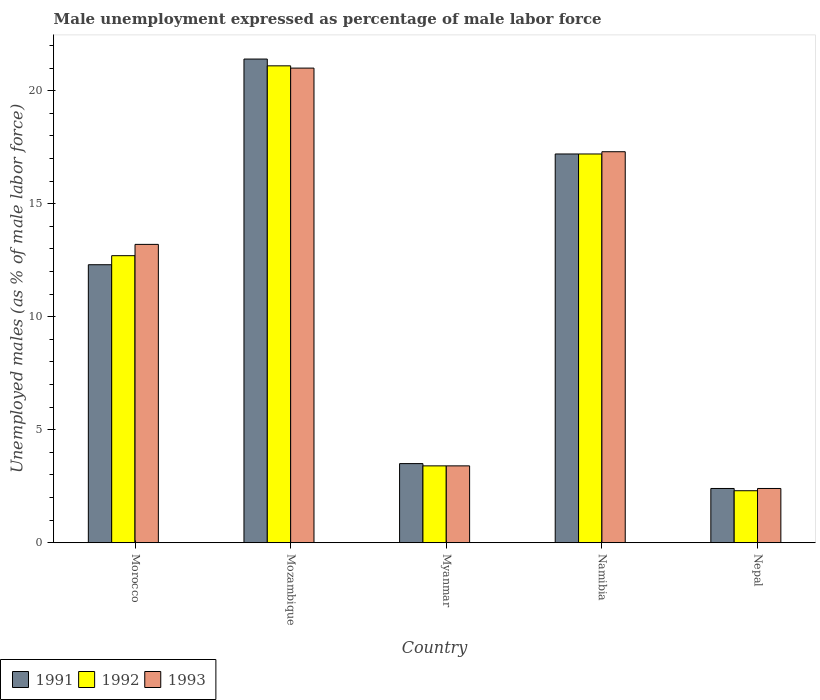How many bars are there on the 2nd tick from the left?
Keep it short and to the point. 3. What is the label of the 1st group of bars from the left?
Your response must be concise. Morocco. What is the unemployment in males in in 1992 in Myanmar?
Provide a short and direct response. 3.4. Across all countries, what is the maximum unemployment in males in in 1992?
Your answer should be compact. 21.1. Across all countries, what is the minimum unemployment in males in in 1993?
Offer a very short reply. 2.4. In which country was the unemployment in males in in 1993 maximum?
Provide a succinct answer. Mozambique. In which country was the unemployment in males in in 1992 minimum?
Your response must be concise. Nepal. What is the total unemployment in males in in 1993 in the graph?
Provide a succinct answer. 57.3. What is the difference between the unemployment in males in in 1993 in Mozambique and that in Namibia?
Your answer should be compact. 3.7. What is the difference between the unemployment in males in in 1993 in Mozambique and the unemployment in males in in 1991 in Morocco?
Provide a short and direct response. 8.7. What is the average unemployment in males in in 1992 per country?
Offer a very short reply. 11.34. What is the difference between the unemployment in males in of/in 1992 and unemployment in males in of/in 1991 in Morocco?
Your answer should be very brief. 0.4. What is the ratio of the unemployment in males in in 1992 in Mozambique to that in Nepal?
Provide a short and direct response. 9.17. Is the difference between the unemployment in males in in 1992 in Myanmar and Namibia greater than the difference between the unemployment in males in in 1991 in Myanmar and Namibia?
Give a very brief answer. No. What is the difference between the highest and the second highest unemployment in males in in 1991?
Give a very brief answer. 4.9. What is the difference between the highest and the lowest unemployment in males in in 1991?
Provide a short and direct response. 19. In how many countries, is the unemployment in males in in 1991 greater than the average unemployment in males in in 1991 taken over all countries?
Ensure brevity in your answer.  3. Is the sum of the unemployment in males in in 1991 in Mozambique and Nepal greater than the maximum unemployment in males in in 1993 across all countries?
Offer a terse response. Yes. What does the 3rd bar from the right in Nepal represents?
Provide a succinct answer. 1991. Is it the case that in every country, the sum of the unemployment in males in in 1993 and unemployment in males in in 1991 is greater than the unemployment in males in in 1992?
Ensure brevity in your answer.  Yes. How many bars are there?
Offer a very short reply. 15. Are all the bars in the graph horizontal?
Give a very brief answer. No. How many countries are there in the graph?
Provide a short and direct response. 5. Are the values on the major ticks of Y-axis written in scientific E-notation?
Provide a short and direct response. No. Does the graph contain grids?
Your response must be concise. No. Where does the legend appear in the graph?
Your answer should be very brief. Bottom left. How are the legend labels stacked?
Offer a terse response. Horizontal. What is the title of the graph?
Your answer should be very brief. Male unemployment expressed as percentage of male labor force. Does "2014" appear as one of the legend labels in the graph?
Give a very brief answer. No. What is the label or title of the Y-axis?
Your answer should be compact. Unemployed males (as % of male labor force). What is the Unemployed males (as % of male labor force) in 1991 in Morocco?
Provide a short and direct response. 12.3. What is the Unemployed males (as % of male labor force) of 1992 in Morocco?
Keep it short and to the point. 12.7. What is the Unemployed males (as % of male labor force) of 1993 in Morocco?
Make the answer very short. 13.2. What is the Unemployed males (as % of male labor force) of 1991 in Mozambique?
Provide a succinct answer. 21.4. What is the Unemployed males (as % of male labor force) in 1992 in Mozambique?
Your answer should be compact. 21.1. What is the Unemployed males (as % of male labor force) of 1992 in Myanmar?
Your response must be concise. 3.4. What is the Unemployed males (as % of male labor force) in 1993 in Myanmar?
Provide a succinct answer. 3.4. What is the Unemployed males (as % of male labor force) in 1991 in Namibia?
Your answer should be compact. 17.2. What is the Unemployed males (as % of male labor force) in 1992 in Namibia?
Your response must be concise. 17.2. What is the Unemployed males (as % of male labor force) of 1993 in Namibia?
Make the answer very short. 17.3. What is the Unemployed males (as % of male labor force) in 1991 in Nepal?
Give a very brief answer. 2.4. What is the Unemployed males (as % of male labor force) of 1992 in Nepal?
Provide a short and direct response. 2.3. What is the Unemployed males (as % of male labor force) in 1993 in Nepal?
Offer a terse response. 2.4. Across all countries, what is the maximum Unemployed males (as % of male labor force) of 1991?
Provide a succinct answer. 21.4. Across all countries, what is the maximum Unemployed males (as % of male labor force) of 1992?
Your answer should be very brief. 21.1. Across all countries, what is the minimum Unemployed males (as % of male labor force) of 1991?
Provide a short and direct response. 2.4. Across all countries, what is the minimum Unemployed males (as % of male labor force) of 1992?
Keep it short and to the point. 2.3. Across all countries, what is the minimum Unemployed males (as % of male labor force) in 1993?
Offer a very short reply. 2.4. What is the total Unemployed males (as % of male labor force) in 1991 in the graph?
Your answer should be very brief. 56.8. What is the total Unemployed males (as % of male labor force) in 1992 in the graph?
Keep it short and to the point. 56.7. What is the total Unemployed males (as % of male labor force) in 1993 in the graph?
Your answer should be very brief. 57.3. What is the difference between the Unemployed males (as % of male labor force) in 1992 in Morocco and that in Mozambique?
Your response must be concise. -8.4. What is the difference between the Unemployed males (as % of male labor force) of 1991 in Morocco and that in Myanmar?
Make the answer very short. 8.8. What is the difference between the Unemployed males (as % of male labor force) in 1993 in Morocco and that in Myanmar?
Keep it short and to the point. 9.8. What is the difference between the Unemployed males (as % of male labor force) in 1992 in Morocco and that in Nepal?
Give a very brief answer. 10.4. What is the difference between the Unemployed males (as % of male labor force) of 1992 in Mozambique and that in Myanmar?
Keep it short and to the point. 17.7. What is the difference between the Unemployed males (as % of male labor force) of 1991 in Mozambique and that in Nepal?
Provide a short and direct response. 19. What is the difference between the Unemployed males (as % of male labor force) of 1993 in Mozambique and that in Nepal?
Ensure brevity in your answer.  18.6. What is the difference between the Unemployed males (as % of male labor force) in 1991 in Myanmar and that in Namibia?
Give a very brief answer. -13.7. What is the difference between the Unemployed males (as % of male labor force) of 1993 in Myanmar and that in Namibia?
Make the answer very short. -13.9. What is the difference between the Unemployed males (as % of male labor force) in 1991 in Myanmar and that in Nepal?
Ensure brevity in your answer.  1.1. What is the difference between the Unemployed males (as % of male labor force) of 1992 in Myanmar and that in Nepal?
Keep it short and to the point. 1.1. What is the difference between the Unemployed males (as % of male labor force) of 1993 in Myanmar and that in Nepal?
Provide a succinct answer. 1. What is the difference between the Unemployed males (as % of male labor force) in 1991 in Namibia and that in Nepal?
Keep it short and to the point. 14.8. What is the difference between the Unemployed males (as % of male labor force) in 1991 in Morocco and the Unemployed males (as % of male labor force) in 1992 in Mozambique?
Your answer should be compact. -8.8. What is the difference between the Unemployed males (as % of male labor force) of 1991 in Morocco and the Unemployed males (as % of male labor force) of 1993 in Mozambique?
Provide a succinct answer. -8.7. What is the difference between the Unemployed males (as % of male labor force) of 1992 in Morocco and the Unemployed males (as % of male labor force) of 1993 in Mozambique?
Provide a short and direct response. -8.3. What is the difference between the Unemployed males (as % of male labor force) of 1991 in Morocco and the Unemployed males (as % of male labor force) of 1993 in Myanmar?
Make the answer very short. 8.9. What is the difference between the Unemployed males (as % of male labor force) of 1991 in Morocco and the Unemployed males (as % of male labor force) of 1993 in Namibia?
Provide a short and direct response. -5. What is the difference between the Unemployed males (as % of male labor force) in 1992 in Morocco and the Unemployed males (as % of male labor force) in 1993 in Namibia?
Your answer should be very brief. -4.6. What is the difference between the Unemployed males (as % of male labor force) in 1991 in Morocco and the Unemployed males (as % of male labor force) in 1992 in Nepal?
Ensure brevity in your answer.  10. What is the difference between the Unemployed males (as % of male labor force) of 1991 in Morocco and the Unemployed males (as % of male labor force) of 1993 in Nepal?
Give a very brief answer. 9.9. What is the difference between the Unemployed males (as % of male labor force) of 1992 in Morocco and the Unemployed males (as % of male labor force) of 1993 in Nepal?
Your response must be concise. 10.3. What is the difference between the Unemployed males (as % of male labor force) of 1992 in Mozambique and the Unemployed males (as % of male labor force) of 1993 in Myanmar?
Provide a short and direct response. 17.7. What is the difference between the Unemployed males (as % of male labor force) in 1991 in Mozambique and the Unemployed males (as % of male labor force) in 1993 in Namibia?
Keep it short and to the point. 4.1. What is the difference between the Unemployed males (as % of male labor force) of 1992 in Mozambique and the Unemployed males (as % of male labor force) of 1993 in Namibia?
Ensure brevity in your answer.  3.8. What is the difference between the Unemployed males (as % of male labor force) in 1991 in Mozambique and the Unemployed males (as % of male labor force) in 1992 in Nepal?
Offer a very short reply. 19.1. What is the difference between the Unemployed males (as % of male labor force) of 1991 in Mozambique and the Unemployed males (as % of male labor force) of 1993 in Nepal?
Offer a very short reply. 19. What is the difference between the Unemployed males (as % of male labor force) of 1992 in Mozambique and the Unemployed males (as % of male labor force) of 1993 in Nepal?
Offer a very short reply. 18.7. What is the difference between the Unemployed males (as % of male labor force) of 1991 in Myanmar and the Unemployed males (as % of male labor force) of 1992 in Namibia?
Offer a very short reply. -13.7. What is the difference between the Unemployed males (as % of male labor force) of 1991 in Myanmar and the Unemployed males (as % of male labor force) of 1993 in Namibia?
Give a very brief answer. -13.8. What is the difference between the Unemployed males (as % of male labor force) in 1992 in Myanmar and the Unemployed males (as % of male labor force) in 1993 in Namibia?
Make the answer very short. -13.9. What is the difference between the Unemployed males (as % of male labor force) of 1991 in Myanmar and the Unemployed males (as % of male labor force) of 1992 in Nepal?
Ensure brevity in your answer.  1.2. What is the difference between the Unemployed males (as % of male labor force) of 1991 in Namibia and the Unemployed males (as % of male labor force) of 1993 in Nepal?
Your answer should be compact. 14.8. What is the average Unemployed males (as % of male labor force) of 1991 per country?
Provide a succinct answer. 11.36. What is the average Unemployed males (as % of male labor force) in 1992 per country?
Offer a very short reply. 11.34. What is the average Unemployed males (as % of male labor force) of 1993 per country?
Your answer should be very brief. 11.46. What is the difference between the Unemployed males (as % of male labor force) in 1992 and Unemployed males (as % of male labor force) in 1993 in Morocco?
Ensure brevity in your answer.  -0.5. What is the difference between the Unemployed males (as % of male labor force) in 1991 and Unemployed males (as % of male labor force) in 1992 in Mozambique?
Keep it short and to the point. 0.3. What is the difference between the Unemployed males (as % of male labor force) in 1992 and Unemployed males (as % of male labor force) in 1993 in Mozambique?
Make the answer very short. 0.1. What is the difference between the Unemployed males (as % of male labor force) in 1991 and Unemployed males (as % of male labor force) in 1992 in Myanmar?
Offer a terse response. 0.1. What is the difference between the Unemployed males (as % of male labor force) of 1992 and Unemployed males (as % of male labor force) of 1993 in Myanmar?
Make the answer very short. 0. What is the difference between the Unemployed males (as % of male labor force) of 1991 and Unemployed males (as % of male labor force) of 1993 in Namibia?
Keep it short and to the point. -0.1. What is the difference between the Unemployed males (as % of male labor force) of 1992 and Unemployed males (as % of male labor force) of 1993 in Namibia?
Your answer should be compact. -0.1. What is the difference between the Unemployed males (as % of male labor force) of 1991 and Unemployed males (as % of male labor force) of 1992 in Nepal?
Offer a very short reply. 0.1. What is the difference between the Unemployed males (as % of male labor force) of 1991 and Unemployed males (as % of male labor force) of 1993 in Nepal?
Ensure brevity in your answer.  0. What is the difference between the Unemployed males (as % of male labor force) in 1992 and Unemployed males (as % of male labor force) in 1993 in Nepal?
Make the answer very short. -0.1. What is the ratio of the Unemployed males (as % of male labor force) in 1991 in Morocco to that in Mozambique?
Provide a short and direct response. 0.57. What is the ratio of the Unemployed males (as % of male labor force) of 1992 in Morocco to that in Mozambique?
Ensure brevity in your answer.  0.6. What is the ratio of the Unemployed males (as % of male labor force) in 1993 in Morocco to that in Mozambique?
Offer a very short reply. 0.63. What is the ratio of the Unemployed males (as % of male labor force) of 1991 in Morocco to that in Myanmar?
Your answer should be very brief. 3.51. What is the ratio of the Unemployed males (as % of male labor force) of 1992 in Morocco to that in Myanmar?
Ensure brevity in your answer.  3.74. What is the ratio of the Unemployed males (as % of male labor force) of 1993 in Morocco to that in Myanmar?
Give a very brief answer. 3.88. What is the ratio of the Unemployed males (as % of male labor force) of 1991 in Morocco to that in Namibia?
Provide a succinct answer. 0.72. What is the ratio of the Unemployed males (as % of male labor force) of 1992 in Morocco to that in Namibia?
Offer a very short reply. 0.74. What is the ratio of the Unemployed males (as % of male labor force) of 1993 in Morocco to that in Namibia?
Your response must be concise. 0.76. What is the ratio of the Unemployed males (as % of male labor force) of 1991 in Morocco to that in Nepal?
Your response must be concise. 5.12. What is the ratio of the Unemployed males (as % of male labor force) of 1992 in Morocco to that in Nepal?
Offer a very short reply. 5.52. What is the ratio of the Unemployed males (as % of male labor force) in 1991 in Mozambique to that in Myanmar?
Your answer should be very brief. 6.11. What is the ratio of the Unemployed males (as % of male labor force) of 1992 in Mozambique to that in Myanmar?
Make the answer very short. 6.21. What is the ratio of the Unemployed males (as % of male labor force) of 1993 in Mozambique to that in Myanmar?
Your response must be concise. 6.18. What is the ratio of the Unemployed males (as % of male labor force) of 1991 in Mozambique to that in Namibia?
Your response must be concise. 1.24. What is the ratio of the Unemployed males (as % of male labor force) in 1992 in Mozambique to that in Namibia?
Your response must be concise. 1.23. What is the ratio of the Unemployed males (as % of male labor force) of 1993 in Mozambique to that in Namibia?
Make the answer very short. 1.21. What is the ratio of the Unemployed males (as % of male labor force) in 1991 in Mozambique to that in Nepal?
Make the answer very short. 8.92. What is the ratio of the Unemployed males (as % of male labor force) in 1992 in Mozambique to that in Nepal?
Your answer should be very brief. 9.17. What is the ratio of the Unemployed males (as % of male labor force) in 1993 in Mozambique to that in Nepal?
Offer a terse response. 8.75. What is the ratio of the Unemployed males (as % of male labor force) of 1991 in Myanmar to that in Namibia?
Offer a terse response. 0.2. What is the ratio of the Unemployed males (as % of male labor force) in 1992 in Myanmar to that in Namibia?
Make the answer very short. 0.2. What is the ratio of the Unemployed males (as % of male labor force) of 1993 in Myanmar to that in Namibia?
Provide a succinct answer. 0.2. What is the ratio of the Unemployed males (as % of male labor force) of 1991 in Myanmar to that in Nepal?
Keep it short and to the point. 1.46. What is the ratio of the Unemployed males (as % of male labor force) in 1992 in Myanmar to that in Nepal?
Your answer should be very brief. 1.48. What is the ratio of the Unemployed males (as % of male labor force) in 1993 in Myanmar to that in Nepal?
Offer a terse response. 1.42. What is the ratio of the Unemployed males (as % of male labor force) of 1991 in Namibia to that in Nepal?
Offer a very short reply. 7.17. What is the ratio of the Unemployed males (as % of male labor force) of 1992 in Namibia to that in Nepal?
Your answer should be very brief. 7.48. What is the ratio of the Unemployed males (as % of male labor force) in 1993 in Namibia to that in Nepal?
Keep it short and to the point. 7.21. What is the difference between the highest and the second highest Unemployed males (as % of male labor force) of 1991?
Your answer should be very brief. 4.2. What is the difference between the highest and the lowest Unemployed males (as % of male labor force) in 1992?
Offer a very short reply. 18.8. 